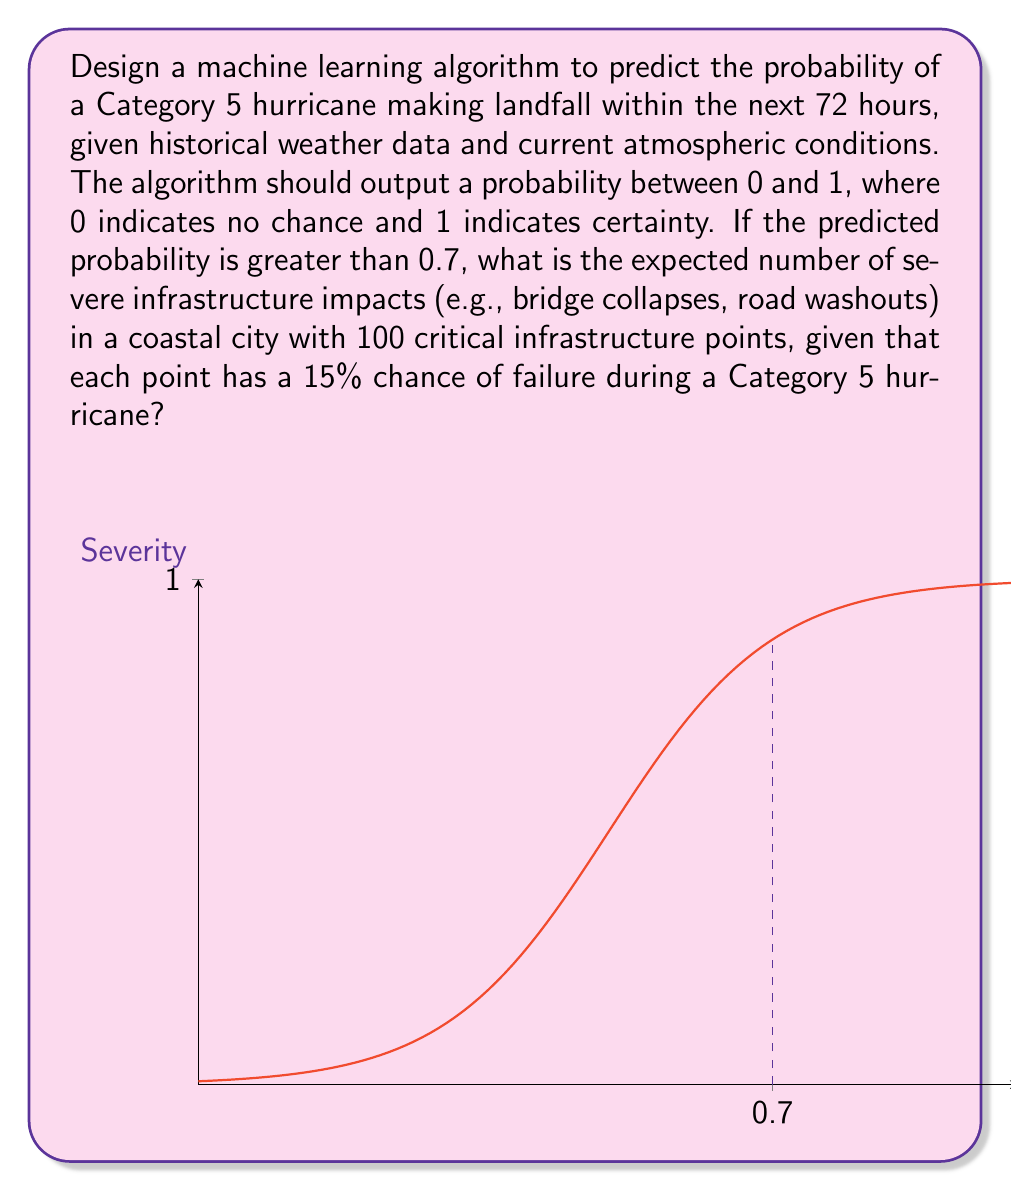Provide a solution to this math problem. To solve this problem, we'll follow these steps:

1) First, we need to understand that the question is conditional. We only consider the case where the predicted probability is greater than 0.7.

2) Given that the probability is greater than 0.7, we assume a Category 5 hurricane will make landfall.

3) We're told that each of the 100 critical infrastructure points has a 15% chance of failure during a Category 5 hurricane.

4) This scenario follows a binomial distribution, where:
   $n = 100$ (number of trials)
   $p = 0.15$ (probability of success, or in this case, failure)

5) The expected value of a binomial distribution is given by the formula:

   $E(X) = np$

   Where:
   $E(X)$ is the expected value
   $n$ is the number of trials
   $p$ is the probability of success

6) Plugging in our values:

   $E(X) = 100 * 0.15 = 15$

Therefore, the expected number of severe infrastructure impacts is 15.
Answer: 15 